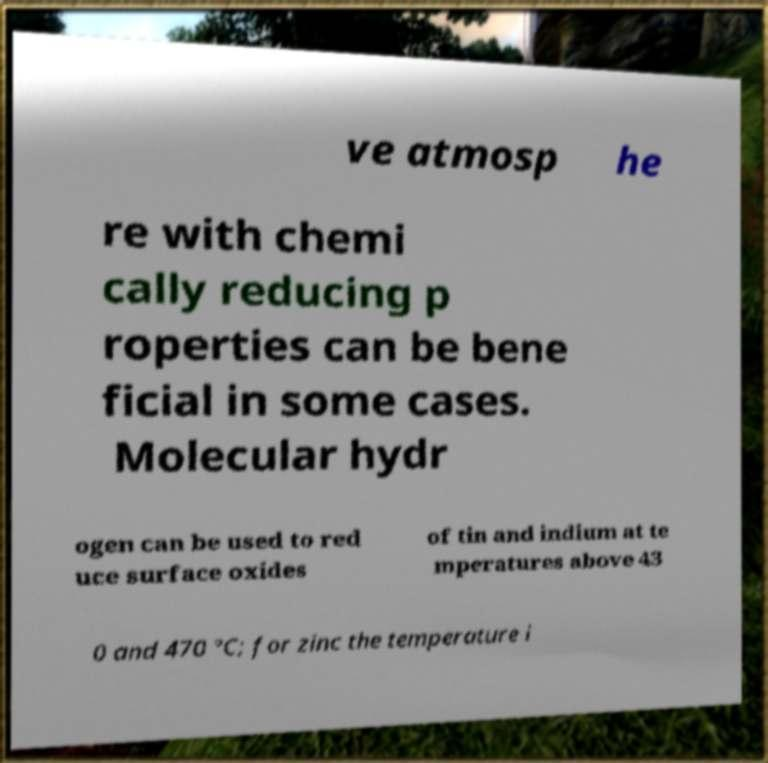Can you read and provide the text displayed in the image?This photo seems to have some interesting text. Can you extract and type it out for me? ve atmosp he re with chemi cally reducing p roperties can be bene ficial in some cases. Molecular hydr ogen can be used to red uce surface oxides of tin and indium at te mperatures above 43 0 and 470 °C; for zinc the temperature i 